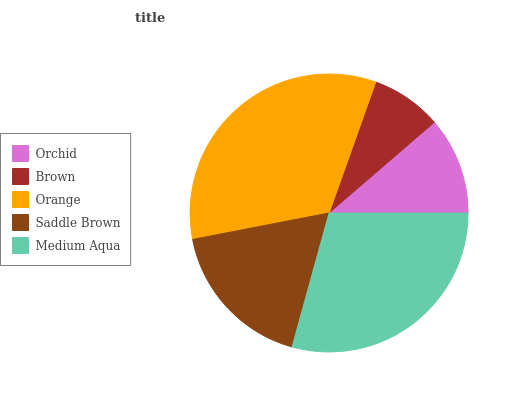Is Brown the minimum?
Answer yes or no. Yes. Is Orange the maximum?
Answer yes or no. Yes. Is Orange the minimum?
Answer yes or no. No. Is Brown the maximum?
Answer yes or no. No. Is Orange greater than Brown?
Answer yes or no. Yes. Is Brown less than Orange?
Answer yes or no. Yes. Is Brown greater than Orange?
Answer yes or no. No. Is Orange less than Brown?
Answer yes or no. No. Is Saddle Brown the high median?
Answer yes or no. Yes. Is Saddle Brown the low median?
Answer yes or no. Yes. Is Orchid the high median?
Answer yes or no. No. Is Orange the low median?
Answer yes or no. No. 